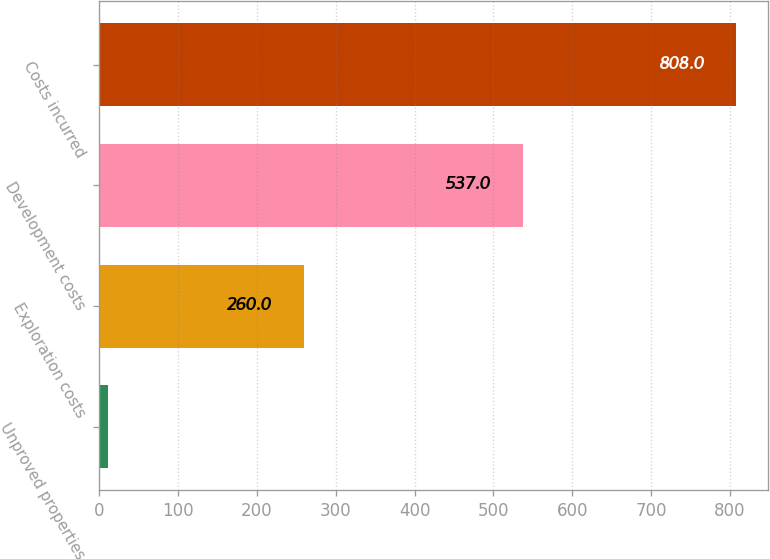<chart> <loc_0><loc_0><loc_500><loc_500><bar_chart><fcel>Unproved properties<fcel>Exploration costs<fcel>Development costs<fcel>Costs incurred<nl><fcel>11<fcel>260<fcel>537<fcel>808<nl></chart> 